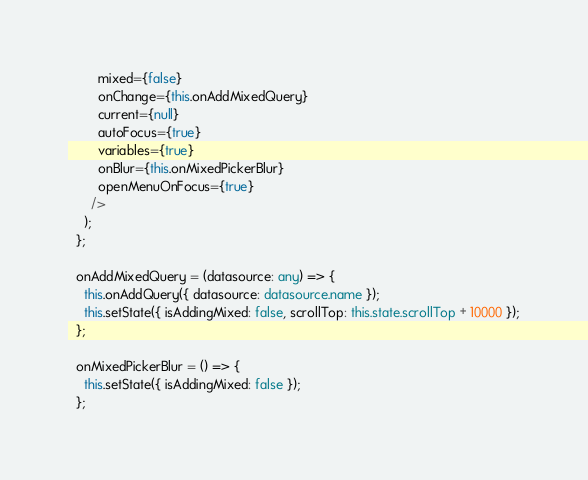<code> <loc_0><loc_0><loc_500><loc_500><_TypeScript_>        mixed={false}
        onChange={this.onAddMixedQuery}
        current={null}
        autoFocus={true}
        variables={true}
        onBlur={this.onMixedPickerBlur}
        openMenuOnFocus={true}
      />
    );
  };

  onAddMixedQuery = (datasource: any) => {
    this.onAddQuery({ datasource: datasource.name });
    this.setState({ isAddingMixed: false, scrollTop: this.state.scrollTop + 10000 });
  };

  onMixedPickerBlur = () => {
    this.setState({ isAddingMixed: false });
  };
</code> 